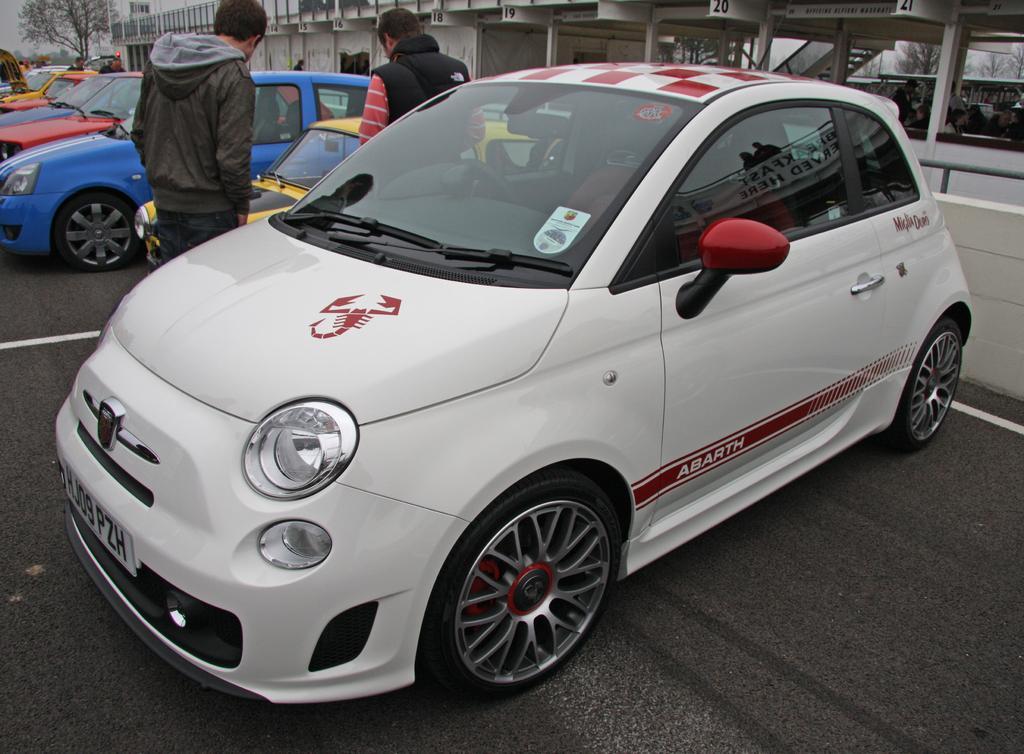Could you give a brief overview of what you see in this image? In front of the picture, we see a white car. At the bottom, we see the road. Beside the car, we see two men are standing. In front of them, we see the cars parked on the road. Behind the car, we see a white wall. Behind that, we see the railing and a buildings in white color. There are trees in the background. 